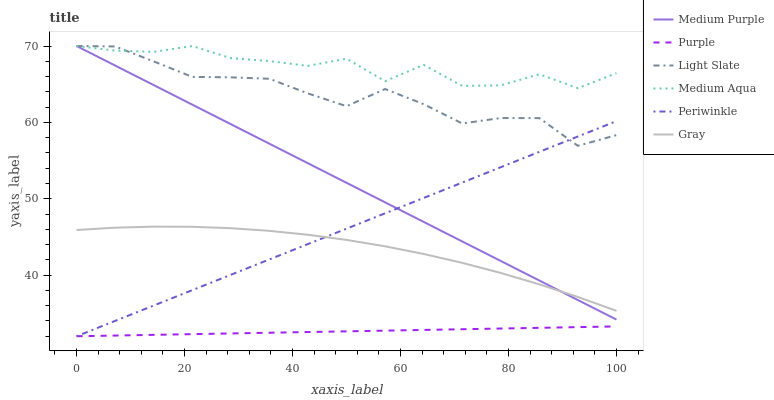Does Medium Purple have the minimum area under the curve?
Answer yes or no. No. Does Medium Purple have the maximum area under the curve?
Answer yes or no. No. Is Medium Purple the smoothest?
Answer yes or no. No. Is Medium Purple the roughest?
Answer yes or no. No. Does Medium Purple have the lowest value?
Answer yes or no. No. Does Purple have the highest value?
Answer yes or no. No. Is Purple less than Medium Purple?
Answer yes or no. Yes. Is Medium Aqua greater than Periwinkle?
Answer yes or no. Yes. Does Purple intersect Medium Purple?
Answer yes or no. No. 